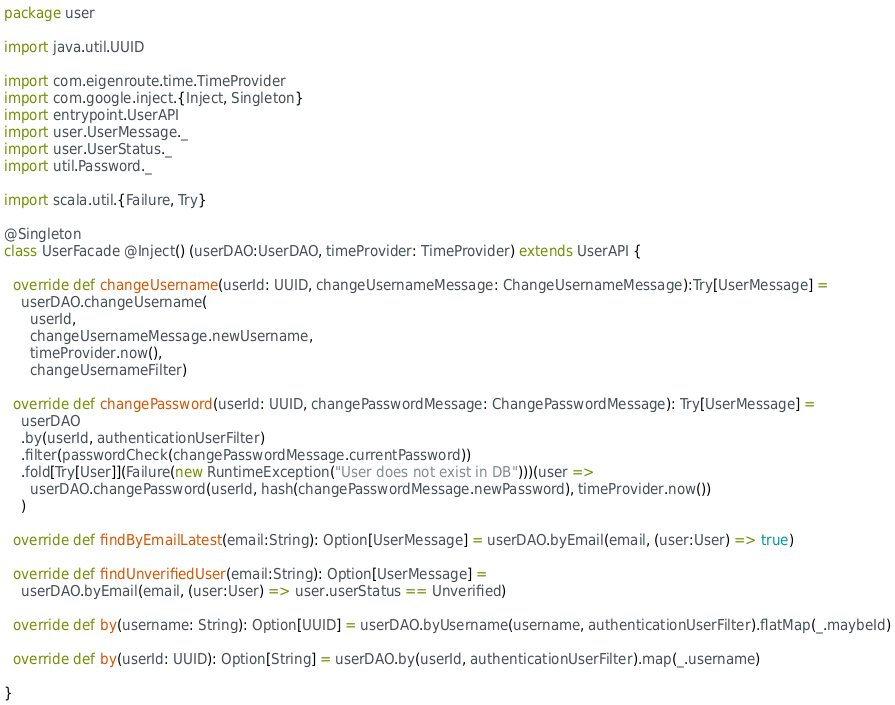<code> <loc_0><loc_0><loc_500><loc_500><_Scala_>package user

import java.util.UUID

import com.eigenroute.time.TimeProvider
import com.google.inject.{Inject, Singleton}
import entrypoint.UserAPI
import user.UserMessage._
import user.UserStatus._
import util.Password._

import scala.util.{Failure, Try}

@Singleton
class UserFacade @Inject() (userDAO:UserDAO, timeProvider: TimeProvider) extends UserAPI {

  override def changeUsername(userId: UUID, changeUsernameMessage: ChangeUsernameMessage):Try[UserMessage] =
    userDAO.changeUsername(
      userId,
      changeUsernameMessage.newUsername,
      timeProvider.now(),
      changeUsernameFilter)

  override def changePassword(userId: UUID, changePasswordMessage: ChangePasswordMessage): Try[UserMessage] =
    userDAO
    .by(userId, authenticationUserFilter)
    .filter(passwordCheck(changePasswordMessage.currentPassword))
    .fold[Try[User]](Failure(new RuntimeException("User does not exist in DB")))(user =>
      userDAO.changePassword(userId, hash(changePasswordMessage.newPassword), timeProvider.now())
    )

  override def findByEmailLatest(email:String): Option[UserMessage] = userDAO.byEmail(email, (user:User) => true)

  override def findUnverifiedUser(email:String): Option[UserMessage] =
    userDAO.byEmail(email, (user:User) => user.userStatus == Unverified)

  override def by(username: String): Option[UUID] = userDAO.byUsername(username, authenticationUserFilter).flatMap(_.maybeId)

  override def by(userId: UUID): Option[String] = userDAO.by(userId, authenticationUserFilter).map(_.username)

}
</code> 